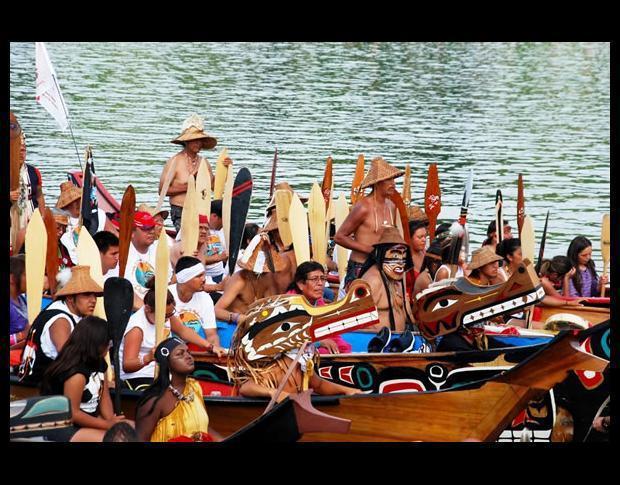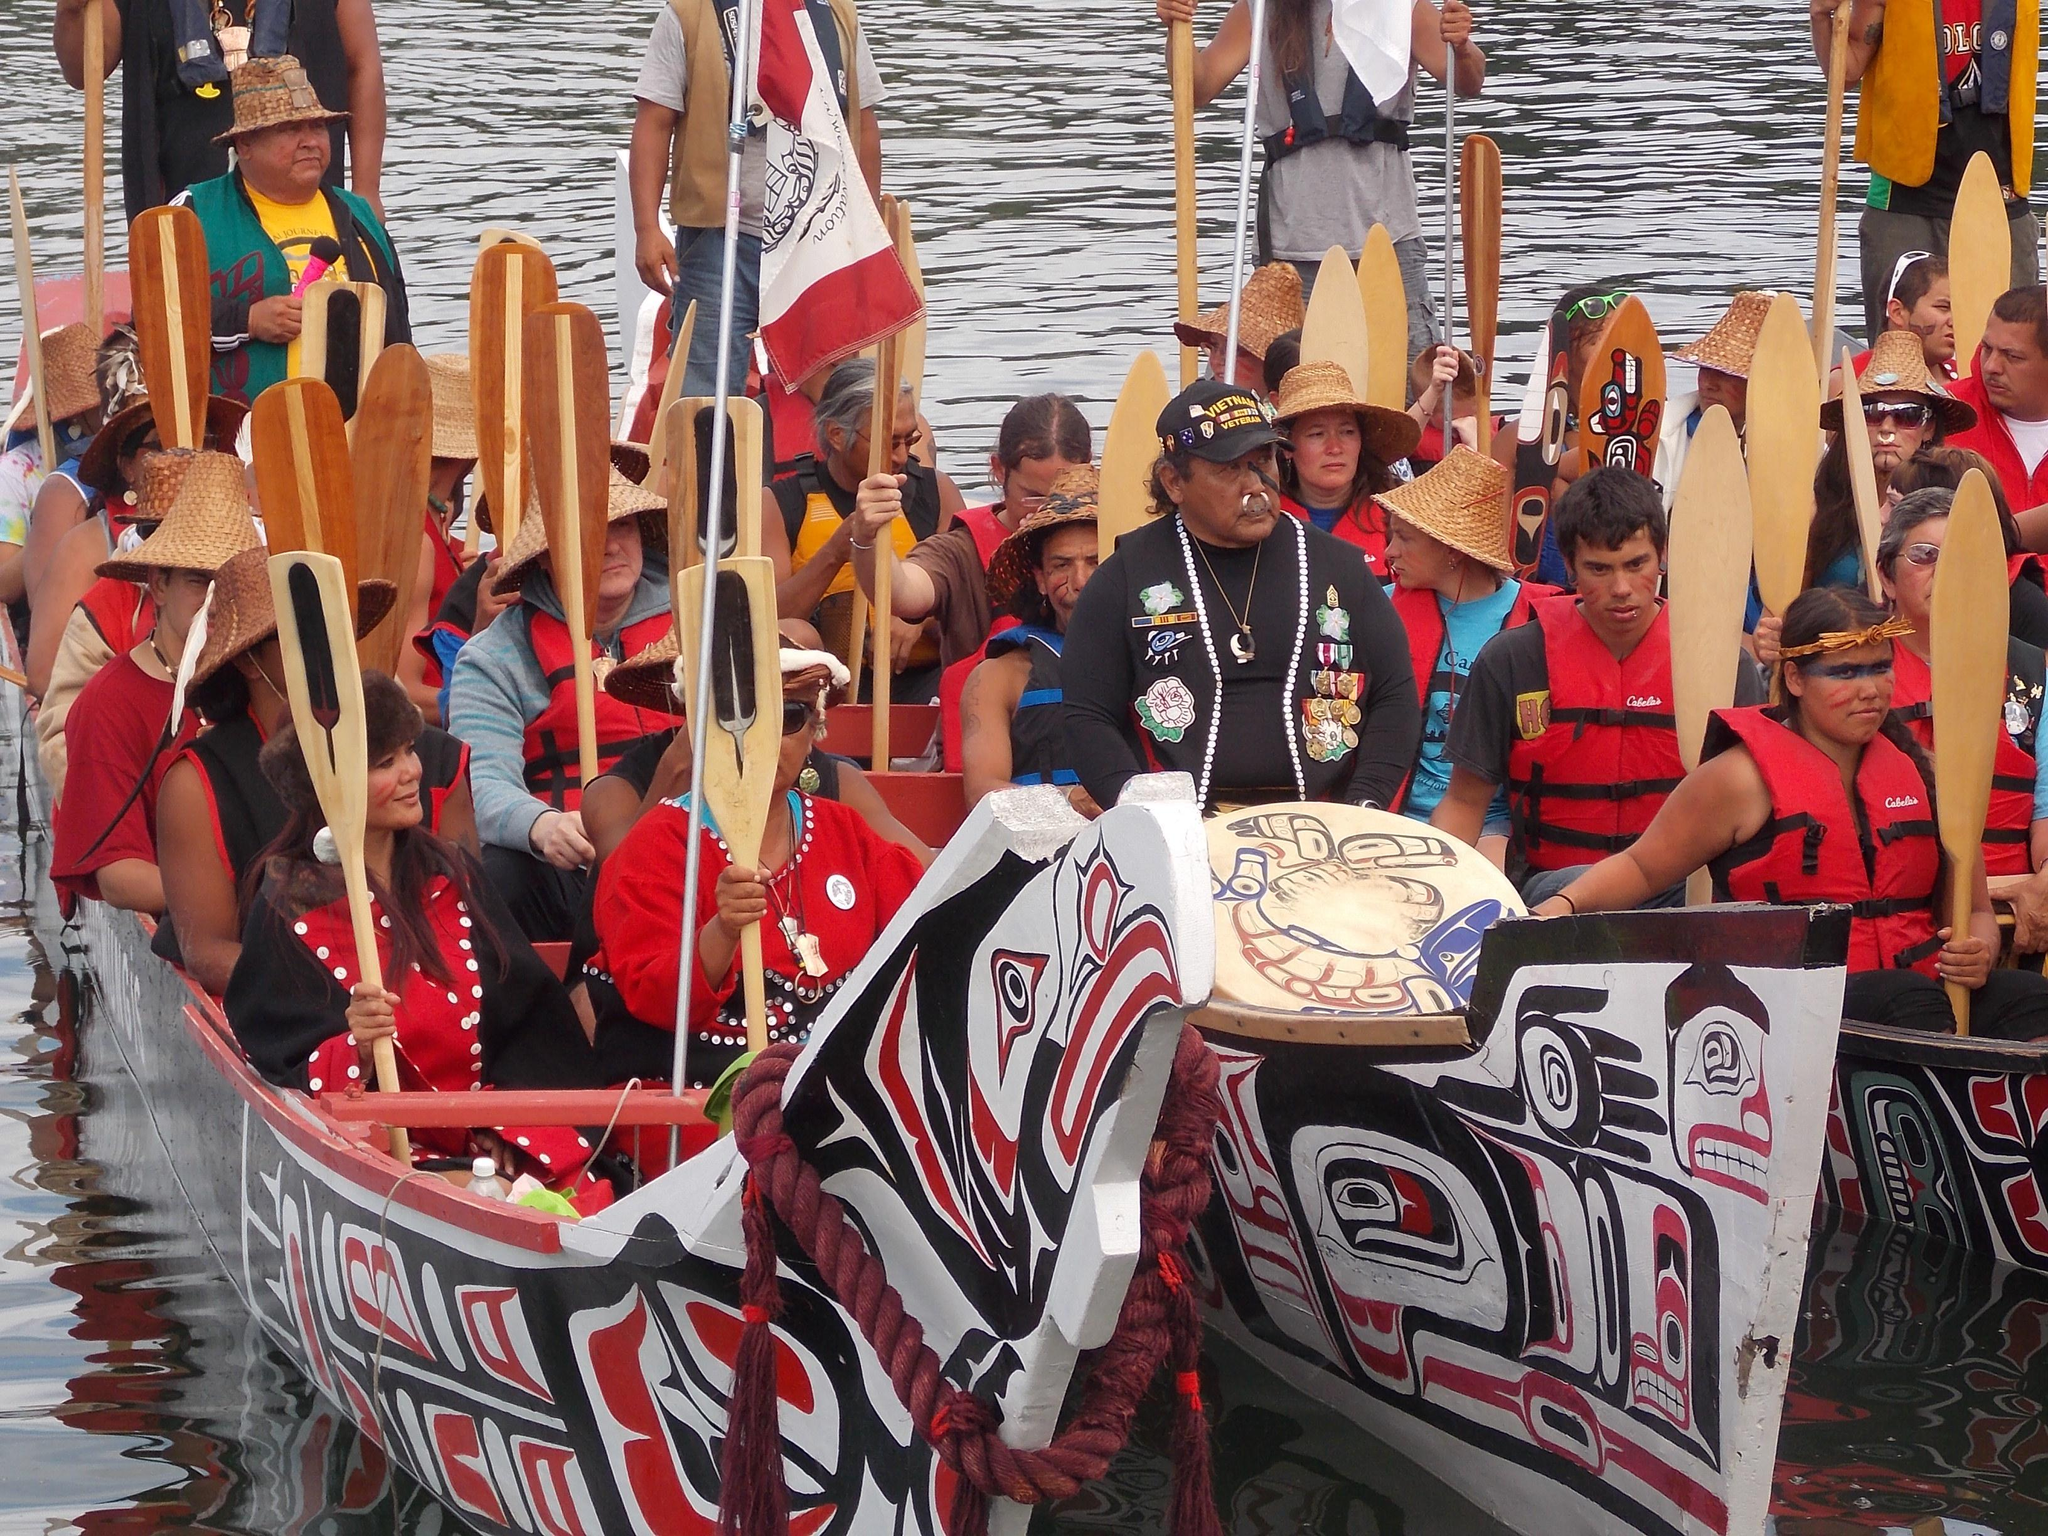The first image is the image on the left, the second image is the image on the right. Examine the images to the left and right. Is the description "At least half a dozen boats sit in the water in the image on the right." accurate? Answer yes or no. No. The first image is the image on the left, the second image is the image on the right. Evaluate the accuracy of this statement regarding the images: "One of the images contains three or less boats.". Is it true? Answer yes or no. Yes. 